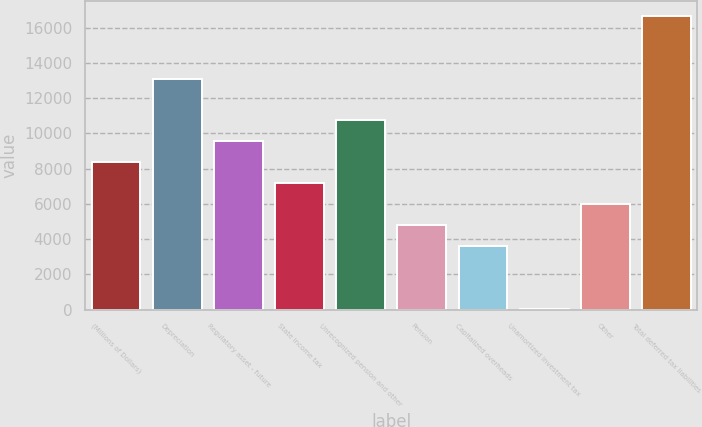Convert chart. <chart><loc_0><loc_0><loc_500><loc_500><bar_chart><fcel>(Millions of Dollars)<fcel>Depreciation<fcel>Regulatory asset - future<fcel>State income tax<fcel>Unrecognized pension and other<fcel>Pension<fcel>Capitalized overheads<fcel>Unamortized investment tax<fcel>Other<fcel>Total deferred tax liabilities<nl><fcel>8361.5<fcel>13111.5<fcel>9549<fcel>7174<fcel>10736.5<fcel>4799<fcel>3611.5<fcel>49<fcel>5986.5<fcel>16674<nl></chart> 